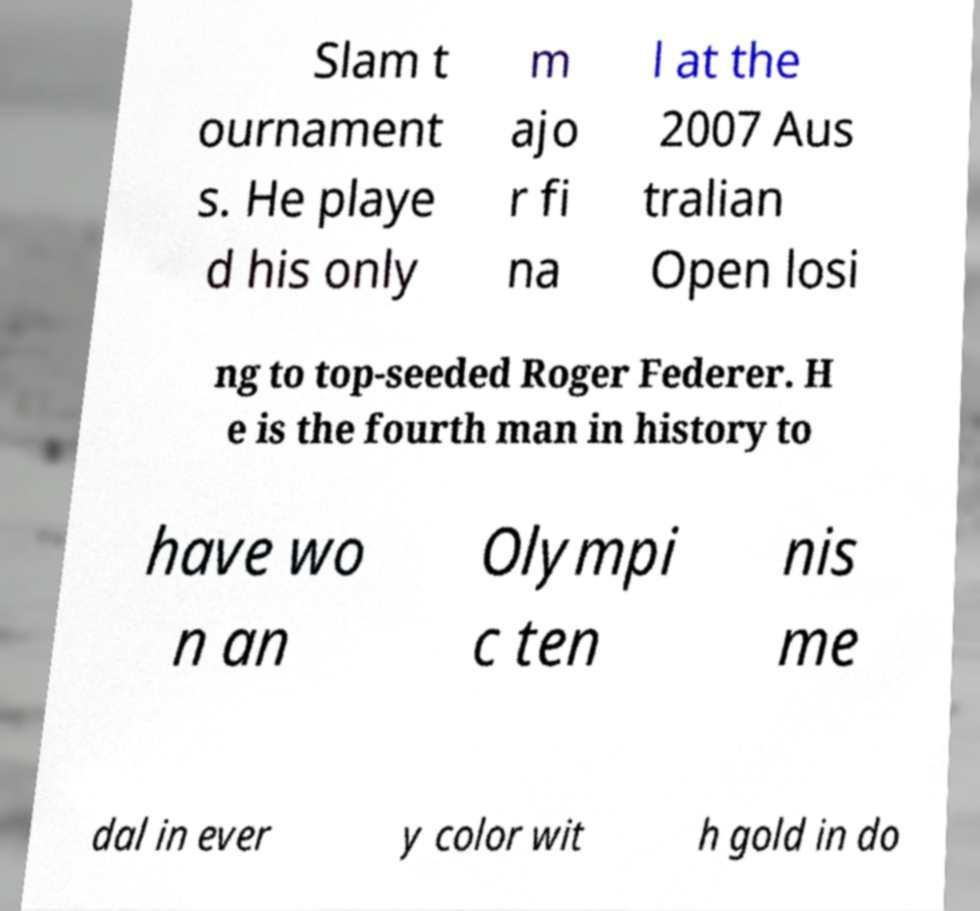I need the written content from this picture converted into text. Can you do that? Slam t ournament s. He playe d his only m ajo r fi na l at the 2007 Aus tralian Open losi ng to top-seeded Roger Federer. H e is the fourth man in history to have wo n an Olympi c ten nis me dal in ever y color wit h gold in do 